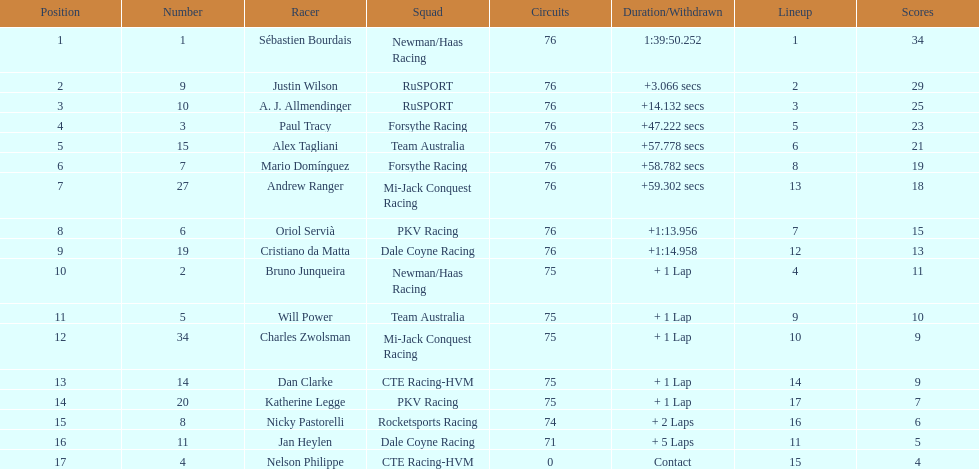What driver earned the most points? Sebastien Bourdais. 